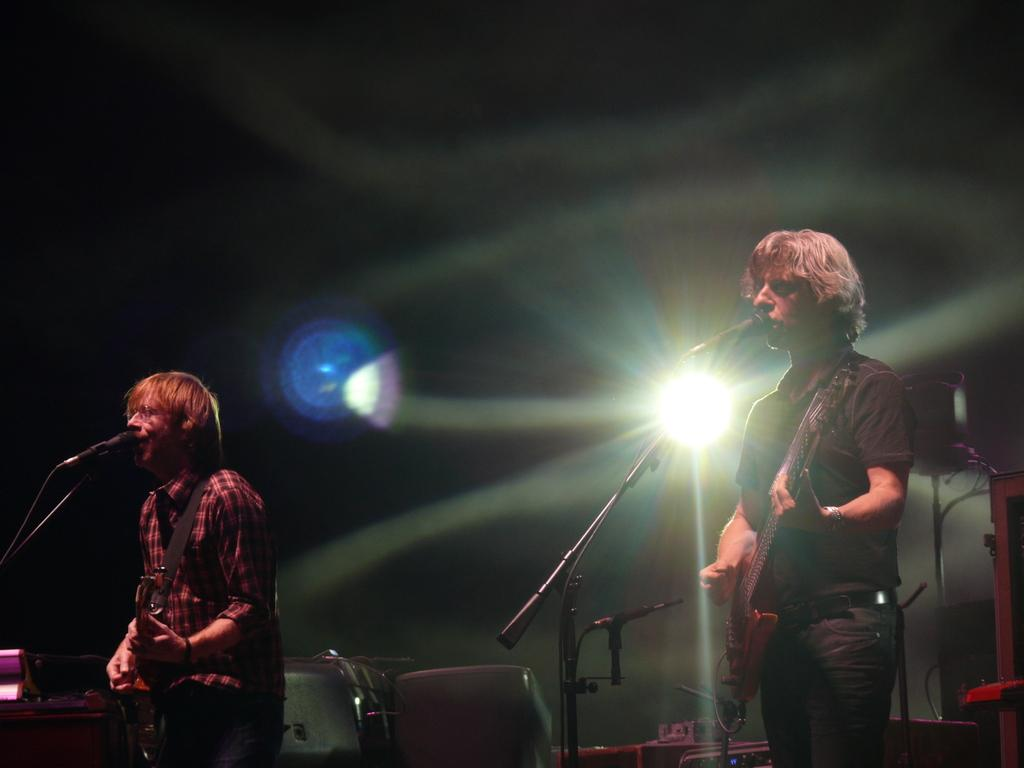How many people are in the image? There are two persons in the image. What are the persons doing in the image? One person is holding a guitar, and the other person is standing in front of a microphone. What is the position of the persons in the image? The persons are standing on the floor. What can be seen in the background of the image? There is light visible in the background of the image. What type of brain surgery is being performed in the image? There is no brain surgery or any medical procedure depicted in the image. The image features two persons, one holding a guitar and the other standing in front of a microphone, with both standing on the floor. 